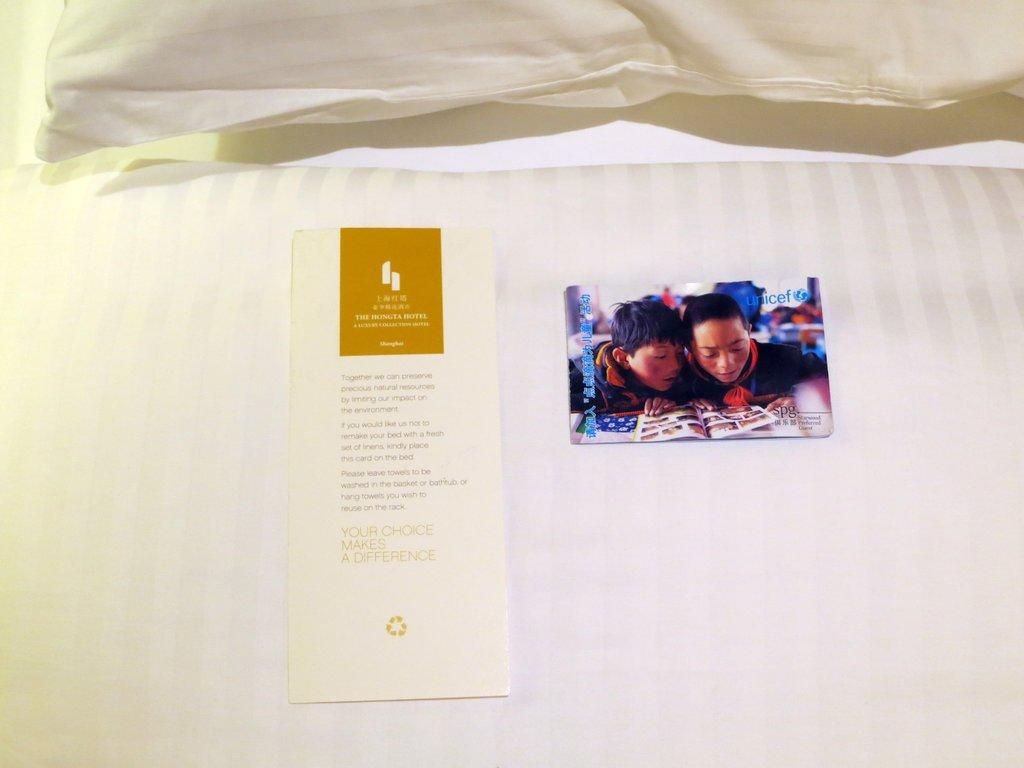What is the main subject of the image? The main subject of the image is a photograph. What else is present in the image besides the photograph? There is paper and a cloth in the image. How are the photograph and paper arranged in the image? The photograph and paper are placed on a cloth. Where is the cloth located in the image? The cloth is in the middle of the image. What other object can be seen at the top of the image? There is a pillow at the top of the image. How many geese are sitting on the pillow in the image? There are no geese present in the image; it only features a photograph, paper, a cloth, and a pillow. 